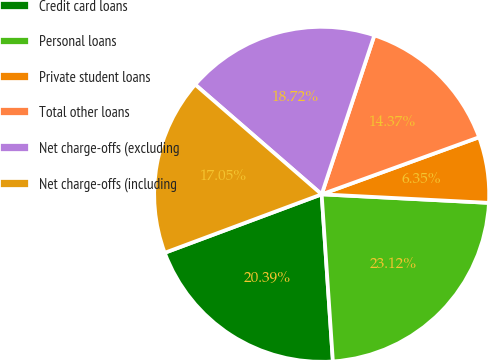Convert chart to OTSL. <chart><loc_0><loc_0><loc_500><loc_500><pie_chart><fcel>Credit card loans<fcel>Personal loans<fcel>Private student loans<fcel>Total other loans<fcel>Net charge-offs (excluding<fcel>Net charge-offs (including<nl><fcel>20.39%<fcel>23.12%<fcel>6.35%<fcel>14.37%<fcel>18.72%<fcel>17.05%<nl></chart> 